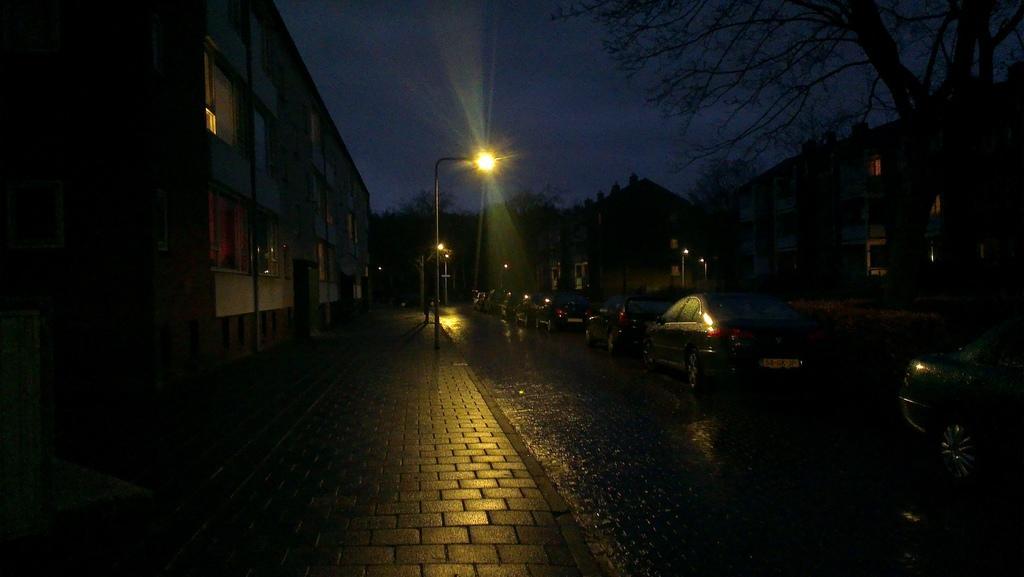In one or two sentences, can you explain what this image depicts? In this picture I can see many cars on the roads. Beside that I can see the street lights. In the background I can see the trees and buildings. At the top there is a sky. 